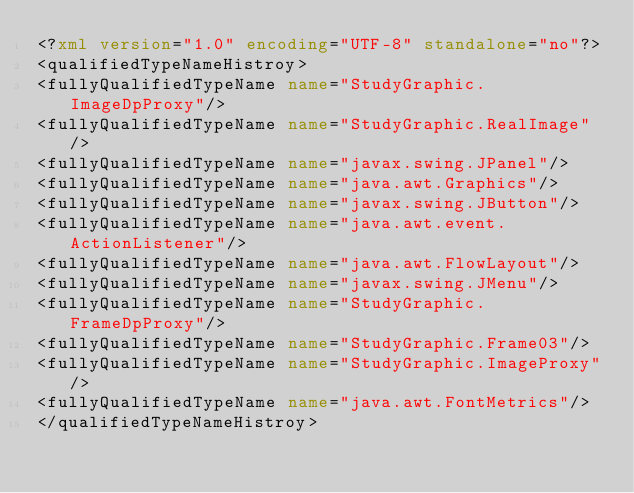<code> <loc_0><loc_0><loc_500><loc_500><_XML_><?xml version="1.0" encoding="UTF-8" standalone="no"?>
<qualifiedTypeNameHistroy>
<fullyQualifiedTypeName name="StudyGraphic.ImageDpProxy"/>
<fullyQualifiedTypeName name="StudyGraphic.RealImage"/>
<fullyQualifiedTypeName name="javax.swing.JPanel"/>
<fullyQualifiedTypeName name="java.awt.Graphics"/>
<fullyQualifiedTypeName name="javax.swing.JButton"/>
<fullyQualifiedTypeName name="java.awt.event.ActionListener"/>
<fullyQualifiedTypeName name="java.awt.FlowLayout"/>
<fullyQualifiedTypeName name="javax.swing.JMenu"/>
<fullyQualifiedTypeName name="StudyGraphic.FrameDpProxy"/>
<fullyQualifiedTypeName name="StudyGraphic.Frame03"/>
<fullyQualifiedTypeName name="StudyGraphic.ImageProxy"/>
<fullyQualifiedTypeName name="java.awt.FontMetrics"/>
</qualifiedTypeNameHistroy>
</code> 